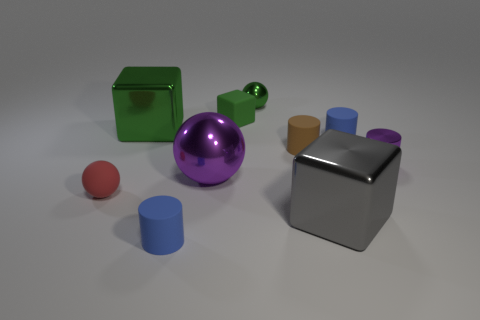Could you describe the shapes and colors of the objects in the image? Certainly! The image features a variety of geometric shapes, including a small red sphere, a large purple ball with a reflective surface, two cylinders — one small and brown, another larger and blue, a small green cube, and a larger gray cube with a metallic finish. The background is nondescript and neutral in color to highlight the objects. 